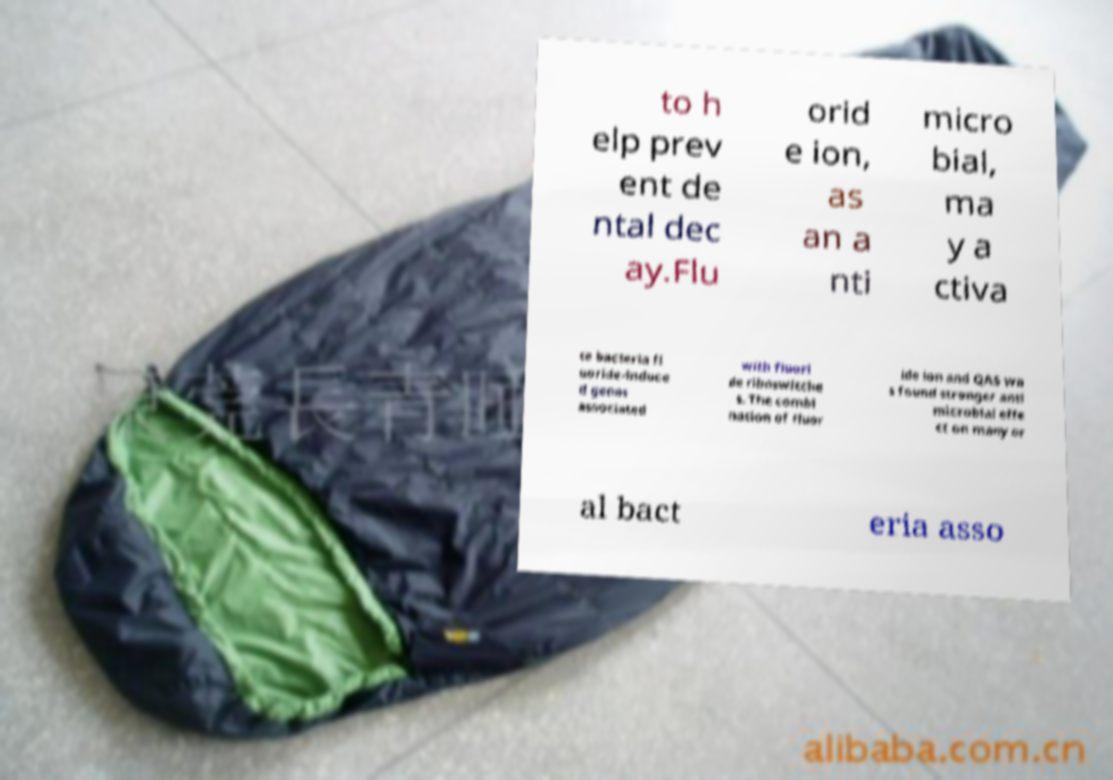Please read and relay the text visible in this image. What does it say? to h elp prev ent de ntal dec ay.Flu orid e ion, as an a nti micro bial, ma y a ctiva te bacteria fl uoride-induce d genes associated with fluori de riboswitche s. The combi nation of fluor ide ion and QAS wa s found stronger anti microbial effe ct on many or al bact eria asso 